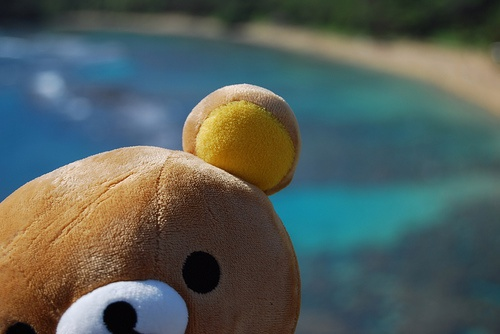Describe the objects in this image and their specific colors. I can see a teddy bear in black, maroon, and olive tones in this image. 